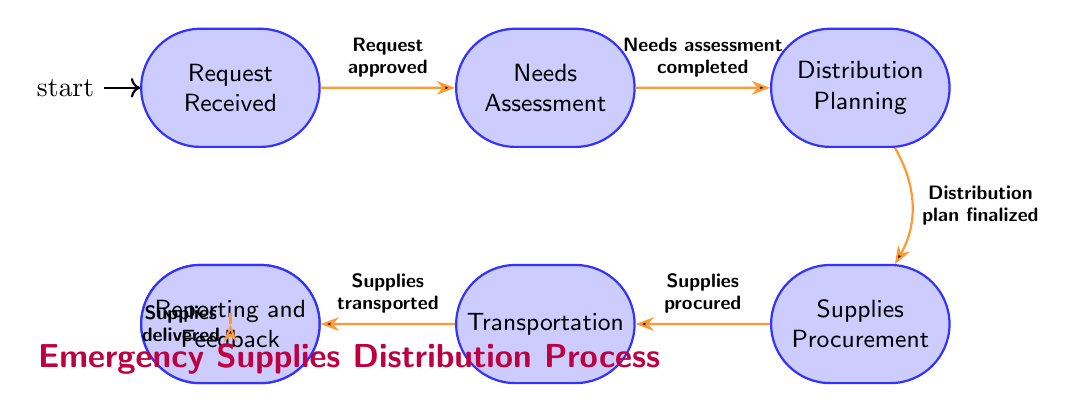What is the first state in the diagram? The first state in the diagram is shown as "Request Received", indicating the initial point where a request for emergency supplies is made.
Answer: Request Received How many states are there in the diagram? By counting the states listed, we find there are seven distinct states: Request Received, Needs Assessment, Distribution Planning, Supplies Procurement, Transportation, Supply Delivery, and Reporting and Feedback.
Answer: 7 What transition leads to the Needs Assessment state? The transition leading to the Needs Assessment state is indicated as occurring from the "Request Received" state when the condition of "Request approved" is met.
Answer: Request approved What is the last state in the sequence? The last state, as shown in the diagram, is "Reporting and Feedback", which follows after the supplies have been delivered to the conflict zone.
Answer: Reporting and Feedback Which state follows the Transportation state? The state that follows the Transportation state, according to the diagram, is "Supply Delivery", where the supplies are ultimately delivered.
Answer: Supply Delivery What condition must be met to proceed from planning to procurement? The condition that must be fulfilled to move from the planning state to the procurement state is "Distribution plan finalized", showing that the planning needs to be completed first.
Answer: Distribution plan finalized What describes the purpose of the Reporting and Feedback state? The Reporting and Feedback state serves the purpose of collecting reports and feedback on the distribution's effectiveness, ensuring learning from the process.
Answer: Collects reports and feedback Which transition involves procurement of supplies? The transition that involves the procurement of supplies is labeled "Supplies procured", signifying that the necessary supplies have been acquired before transportation.
Answer: Supplies procured What happens after the Supply Delivery state? After the Supply Delivery state, the process moves to the Reporting and Feedback state, indicating the final step of evaluating the success of the supply distribution.
Answer: Reporting and Feedback 